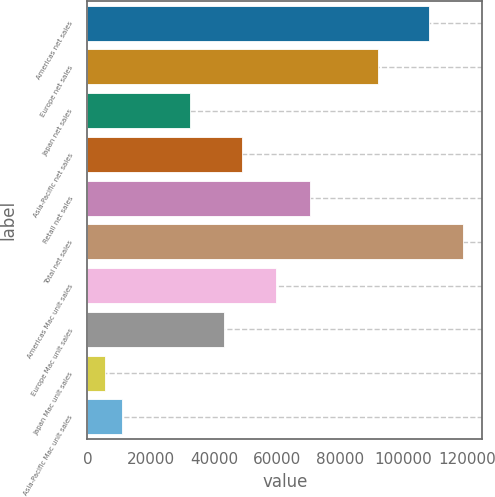Convert chart. <chart><loc_0><loc_0><loc_500><loc_500><bar_chart><fcel>Americas net sales<fcel>Europe net sales<fcel>Japan net sales<fcel>Asia-Pacific net sales<fcel>Retail net sales<fcel>Total net sales<fcel>Americas Mac unit sales<fcel>Europe Mac unit sales<fcel>Japan Mac unit sales<fcel>Asia-Pacific Mac unit sales<nl><fcel>108115<fcel>91920.1<fcel>32538.8<fcel>48733.7<fcel>70326.9<fcel>118912<fcel>59530.3<fcel>43335.4<fcel>5547.3<fcel>10945.6<nl></chart> 